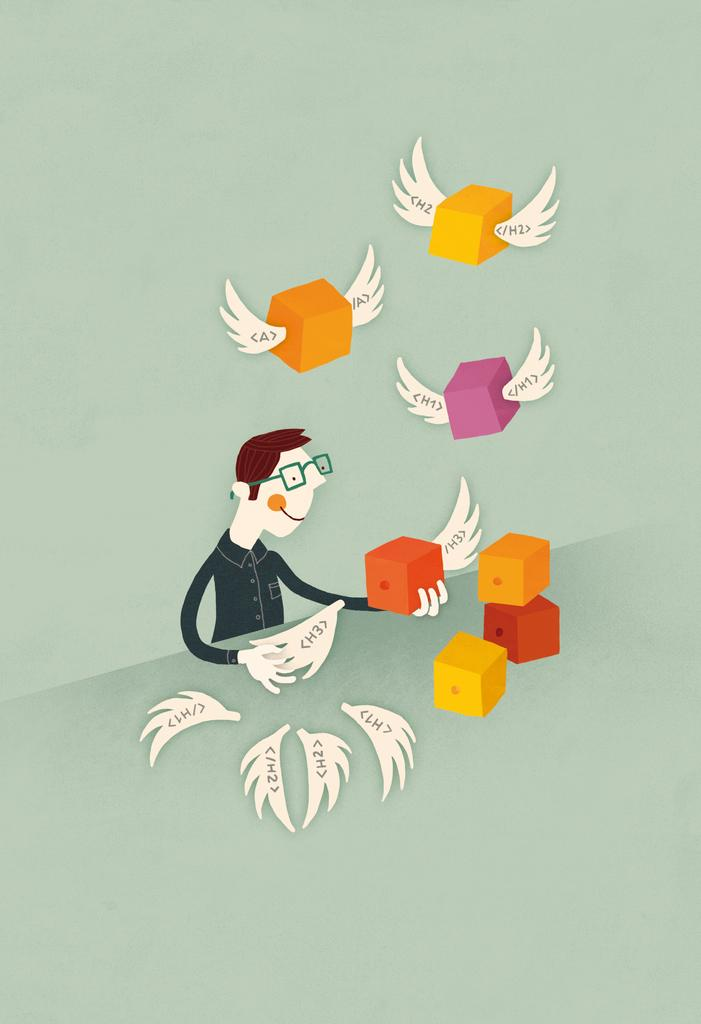What is the main subject of the image? There is a cartoon person sitting in the image. What is the cartoon person doing in the image? The cartoon person is holding objects. Are there any other animated elements in the image? Yes, there are animated cubes with wings in the image. What type of flesh can be seen on the cartoon person's body in the image? The image is of a cartoon person, and cartoons do not have flesh; they are made of lines and colors. 